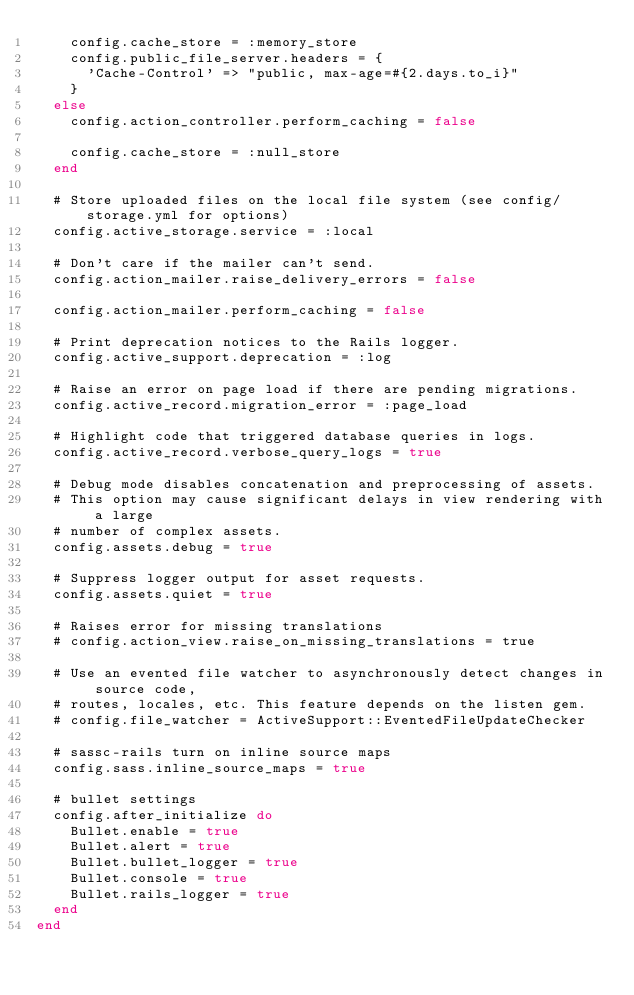Convert code to text. <code><loc_0><loc_0><loc_500><loc_500><_Ruby_>    config.cache_store = :memory_store
    config.public_file_server.headers = {
      'Cache-Control' => "public, max-age=#{2.days.to_i}"
    }
  else
    config.action_controller.perform_caching = false

    config.cache_store = :null_store
  end

  # Store uploaded files on the local file system (see config/storage.yml for options)
  config.active_storage.service = :local

  # Don't care if the mailer can't send.
  config.action_mailer.raise_delivery_errors = false

  config.action_mailer.perform_caching = false

  # Print deprecation notices to the Rails logger.
  config.active_support.deprecation = :log

  # Raise an error on page load if there are pending migrations.
  config.active_record.migration_error = :page_load

  # Highlight code that triggered database queries in logs.
  config.active_record.verbose_query_logs = true

  # Debug mode disables concatenation and preprocessing of assets.
  # This option may cause significant delays in view rendering with a large
  # number of complex assets.
  config.assets.debug = true

  # Suppress logger output for asset requests.
  config.assets.quiet = true

  # Raises error for missing translations
  # config.action_view.raise_on_missing_translations = true

  # Use an evented file watcher to asynchronously detect changes in source code,
  # routes, locales, etc. This feature depends on the listen gem.
  # config.file_watcher = ActiveSupport::EventedFileUpdateChecker

  # sassc-rails turn on inline source maps
  config.sass.inline_source_maps = true

  # bullet settings
  config.after_initialize do
    Bullet.enable = true
    Bullet.alert = true
    Bullet.bullet_logger = true
    Bullet.console = true
    Bullet.rails_logger = true
  end
end
</code> 